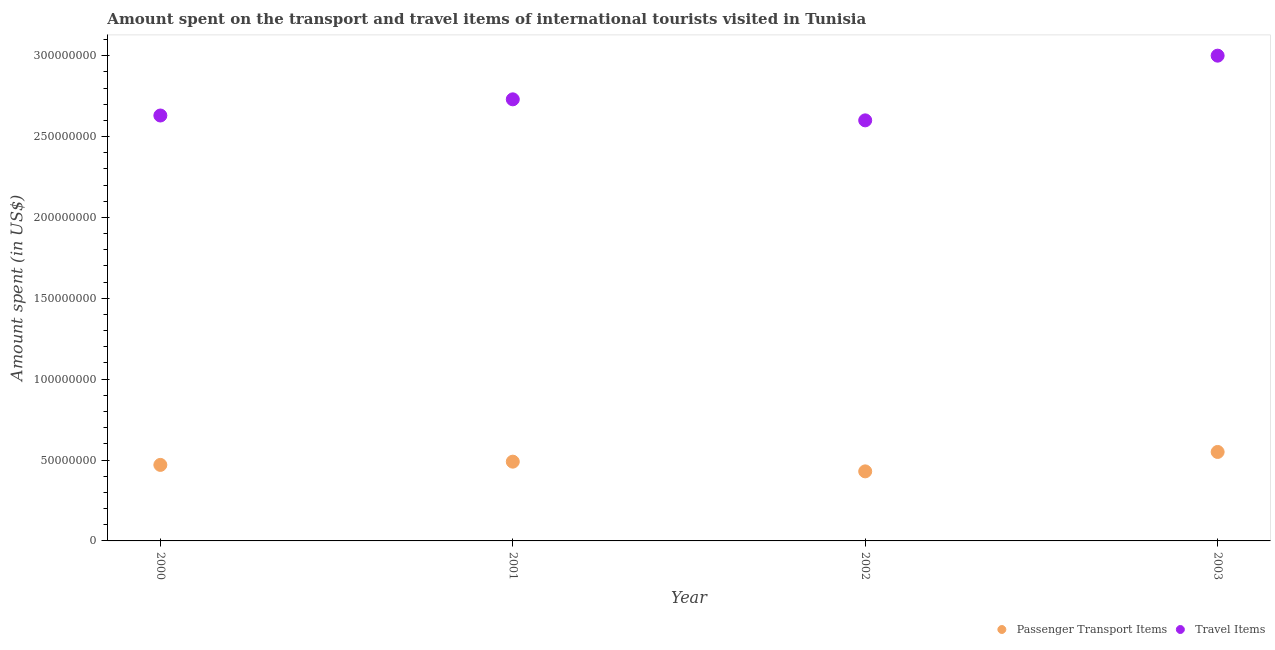How many different coloured dotlines are there?
Offer a terse response. 2. What is the amount spent in travel items in 2000?
Provide a short and direct response. 2.63e+08. Across all years, what is the maximum amount spent in travel items?
Make the answer very short. 3.00e+08. Across all years, what is the minimum amount spent in travel items?
Your answer should be very brief. 2.60e+08. In which year was the amount spent on passenger transport items maximum?
Your answer should be compact. 2003. In which year was the amount spent in travel items minimum?
Offer a terse response. 2002. What is the total amount spent in travel items in the graph?
Provide a succinct answer. 1.10e+09. What is the difference between the amount spent in travel items in 2000 and that in 2003?
Your answer should be very brief. -3.70e+07. What is the difference between the amount spent on passenger transport items in 2002 and the amount spent in travel items in 2000?
Your answer should be very brief. -2.20e+08. What is the average amount spent on passenger transport items per year?
Offer a terse response. 4.85e+07. In the year 2000, what is the difference between the amount spent in travel items and amount spent on passenger transport items?
Your answer should be compact. 2.16e+08. In how many years, is the amount spent in travel items greater than 40000000 US$?
Provide a short and direct response. 4. What is the ratio of the amount spent on passenger transport items in 2002 to that in 2003?
Provide a short and direct response. 0.78. What is the difference between the highest and the second highest amount spent in travel items?
Keep it short and to the point. 2.70e+07. What is the difference between the highest and the lowest amount spent on passenger transport items?
Offer a terse response. 1.20e+07. In how many years, is the amount spent on passenger transport items greater than the average amount spent on passenger transport items taken over all years?
Your response must be concise. 2. Is the sum of the amount spent in travel items in 2000 and 2001 greater than the maximum amount spent on passenger transport items across all years?
Keep it short and to the point. Yes. Is the amount spent in travel items strictly greater than the amount spent on passenger transport items over the years?
Your answer should be compact. Yes. What is the difference between two consecutive major ticks on the Y-axis?
Keep it short and to the point. 5.00e+07. Where does the legend appear in the graph?
Keep it short and to the point. Bottom right. How are the legend labels stacked?
Make the answer very short. Horizontal. What is the title of the graph?
Your response must be concise. Amount spent on the transport and travel items of international tourists visited in Tunisia. Does "Food" appear as one of the legend labels in the graph?
Offer a terse response. No. What is the label or title of the Y-axis?
Offer a very short reply. Amount spent (in US$). What is the Amount spent (in US$) of Passenger Transport Items in 2000?
Your answer should be very brief. 4.70e+07. What is the Amount spent (in US$) of Travel Items in 2000?
Your answer should be compact. 2.63e+08. What is the Amount spent (in US$) of Passenger Transport Items in 2001?
Your answer should be very brief. 4.90e+07. What is the Amount spent (in US$) of Travel Items in 2001?
Your response must be concise. 2.73e+08. What is the Amount spent (in US$) in Passenger Transport Items in 2002?
Keep it short and to the point. 4.30e+07. What is the Amount spent (in US$) in Travel Items in 2002?
Ensure brevity in your answer.  2.60e+08. What is the Amount spent (in US$) of Passenger Transport Items in 2003?
Keep it short and to the point. 5.50e+07. What is the Amount spent (in US$) in Travel Items in 2003?
Offer a terse response. 3.00e+08. Across all years, what is the maximum Amount spent (in US$) in Passenger Transport Items?
Give a very brief answer. 5.50e+07. Across all years, what is the maximum Amount spent (in US$) in Travel Items?
Your answer should be compact. 3.00e+08. Across all years, what is the minimum Amount spent (in US$) of Passenger Transport Items?
Make the answer very short. 4.30e+07. Across all years, what is the minimum Amount spent (in US$) in Travel Items?
Offer a terse response. 2.60e+08. What is the total Amount spent (in US$) of Passenger Transport Items in the graph?
Make the answer very short. 1.94e+08. What is the total Amount spent (in US$) in Travel Items in the graph?
Give a very brief answer. 1.10e+09. What is the difference between the Amount spent (in US$) of Passenger Transport Items in 2000 and that in 2001?
Give a very brief answer. -2.00e+06. What is the difference between the Amount spent (in US$) in Travel Items in 2000 and that in 2001?
Provide a short and direct response. -1.00e+07. What is the difference between the Amount spent (in US$) of Passenger Transport Items in 2000 and that in 2003?
Your response must be concise. -8.00e+06. What is the difference between the Amount spent (in US$) in Travel Items in 2000 and that in 2003?
Offer a very short reply. -3.70e+07. What is the difference between the Amount spent (in US$) of Passenger Transport Items in 2001 and that in 2002?
Your answer should be very brief. 6.00e+06. What is the difference between the Amount spent (in US$) of Travel Items in 2001 and that in 2002?
Provide a short and direct response. 1.30e+07. What is the difference between the Amount spent (in US$) in Passenger Transport Items in 2001 and that in 2003?
Your answer should be compact. -6.00e+06. What is the difference between the Amount spent (in US$) of Travel Items in 2001 and that in 2003?
Provide a succinct answer. -2.70e+07. What is the difference between the Amount spent (in US$) in Passenger Transport Items in 2002 and that in 2003?
Offer a terse response. -1.20e+07. What is the difference between the Amount spent (in US$) in Travel Items in 2002 and that in 2003?
Make the answer very short. -4.00e+07. What is the difference between the Amount spent (in US$) of Passenger Transport Items in 2000 and the Amount spent (in US$) of Travel Items in 2001?
Make the answer very short. -2.26e+08. What is the difference between the Amount spent (in US$) in Passenger Transport Items in 2000 and the Amount spent (in US$) in Travel Items in 2002?
Ensure brevity in your answer.  -2.13e+08. What is the difference between the Amount spent (in US$) of Passenger Transport Items in 2000 and the Amount spent (in US$) of Travel Items in 2003?
Make the answer very short. -2.53e+08. What is the difference between the Amount spent (in US$) in Passenger Transport Items in 2001 and the Amount spent (in US$) in Travel Items in 2002?
Your answer should be very brief. -2.11e+08. What is the difference between the Amount spent (in US$) of Passenger Transport Items in 2001 and the Amount spent (in US$) of Travel Items in 2003?
Your answer should be very brief. -2.51e+08. What is the difference between the Amount spent (in US$) of Passenger Transport Items in 2002 and the Amount spent (in US$) of Travel Items in 2003?
Offer a terse response. -2.57e+08. What is the average Amount spent (in US$) of Passenger Transport Items per year?
Make the answer very short. 4.85e+07. What is the average Amount spent (in US$) in Travel Items per year?
Your answer should be very brief. 2.74e+08. In the year 2000, what is the difference between the Amount spent (in US$) of Passenger Transport Items and Amount spent (in US$) of Travel Items?
Your answer should be compact. -2.16e+08. In the year 2001, what is the difference between the Amount spent (in US$) in Passenger Transport Items and Amount spent (in US$) in Travel Items?
Provide a succinct answer. -2.24e+08. In the year 2002, what is the difference between the Amount spent (in US$) in Passenger Transport Items and Amount spent (in US$) in Travel Items?
Offer a very short reply. -2.17e+08. In the year 2003, what is the difference between the Amount spent (in US$) in Passenger Transport Items and Amount spent (in US$) in Travel Items?
Ensure brevity in your answer.  -2.45e+08. What is the ratio of the Amount spent (in US$) of Passenger Transport Items in 2000 to that in 2001?
Provide a succinct answer. 0.96. What is the ratio of the Amount spent (in US$) in Travel Items in 2000 to that in 2001?
Provide a short and direct response. 0.96. What is the ratio of the Amount spent (in US$) of Passenger Transport Items in 2000 to that in 2002?
Provide a succinct answer. 1.09. What is the ratio of the Amount spent (in US$) of Travel Items in 2000 to that in 2002?
Your response must be concise. 1.01. What is the ratio of the Amount spent (in US$) of Passenger Transport Items in 2000 to that in 2003?
Keep it short and to the point. 0.85. What is the ratio of the Amount spent (in US$) of Travel Items in 2000 to that in 2003?
Your response must be concise. 0.88. What is the ratio of the Amount spent (in US$) of Passenger Transport Items in 2001 to that in 2002?
Your response must be concise. 1.14. What is the ratio of the Amount spent (in US$) of Passenger Transport Items in 2001 to that in 2003?
Your response must be concise. 0.89. What is the ratio of the Amount spent (in US$) of Travel Items in 2001 to that in 2003?
Your answer should be compact. 0.91. What is the ratio of the Amount spent (in US$) of Passenger Transport Items in 2002 to that in 2003?
Give a very brief answer. 0.78. What is the ratio of the Amount spent (in US$) of Travel Items in 2002 to that in 2003?
Make the answer very short. 0.87. What is the difference between the highest and the second highest Amount spent (in US$) of Travel Items?
Your answer should be compact. 2.70e+07. What is the difference between the highest and the lowest Amount spent (in US$) of Passenger Transport Items?
Provide a short and direct response. 1.20e+07. What is the difference between the highest and the lowest Amount spent (in US$) in Travel Items?
Make the answer very short. 4.00e+07. 